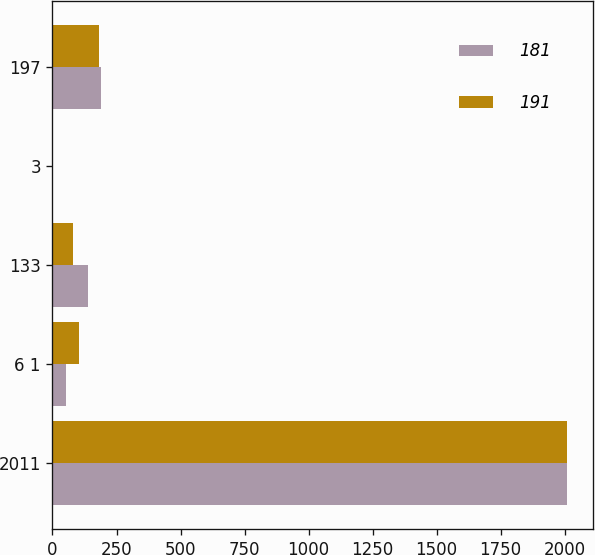Convert chart to OTSL. <chart><loc_0><loc_0><loc_500><loc_500><stacked_bar_chart><ecel><fcel>2011<fcel>6 1<fcel>133<fcel>3<fcel>197<nl><fcel>181<fcel>2010<fcel>52<fcel>139<fcel>0<fcel>191<nl><fcel>191<fcel>2009<fcel>102<fcel>79<fcel>0<fcel>181<nl></chart> 